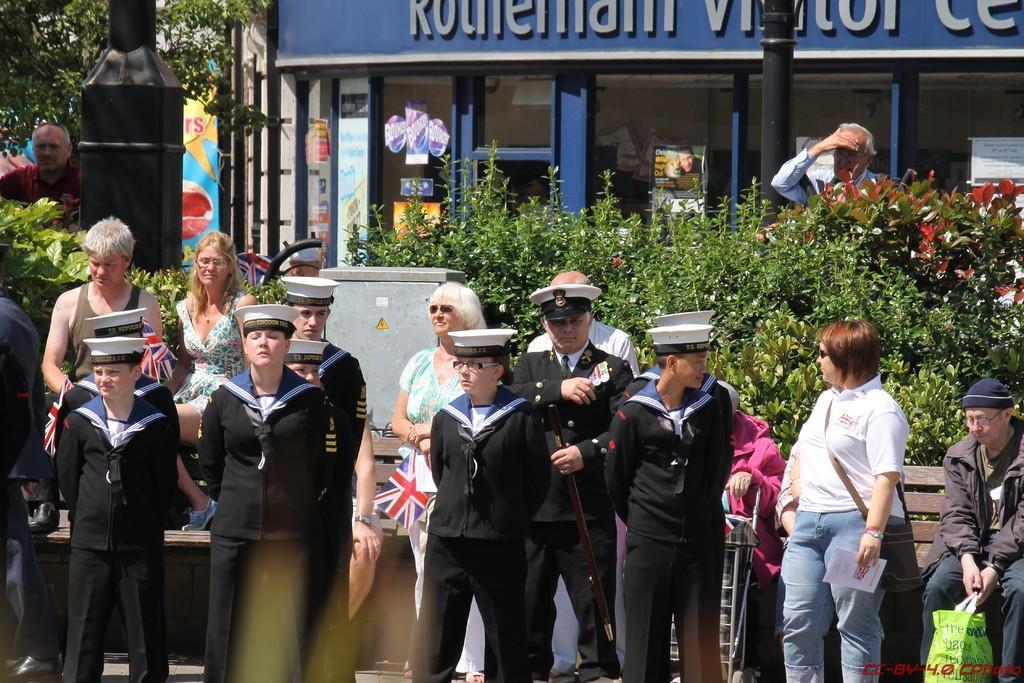Describe this image in one or two sentences. In the image we can see there are people standing and one is sitting, they are wearing clothes and some of them are wearing hats and goggles. Here we can see plant, posters, pole and the text. 